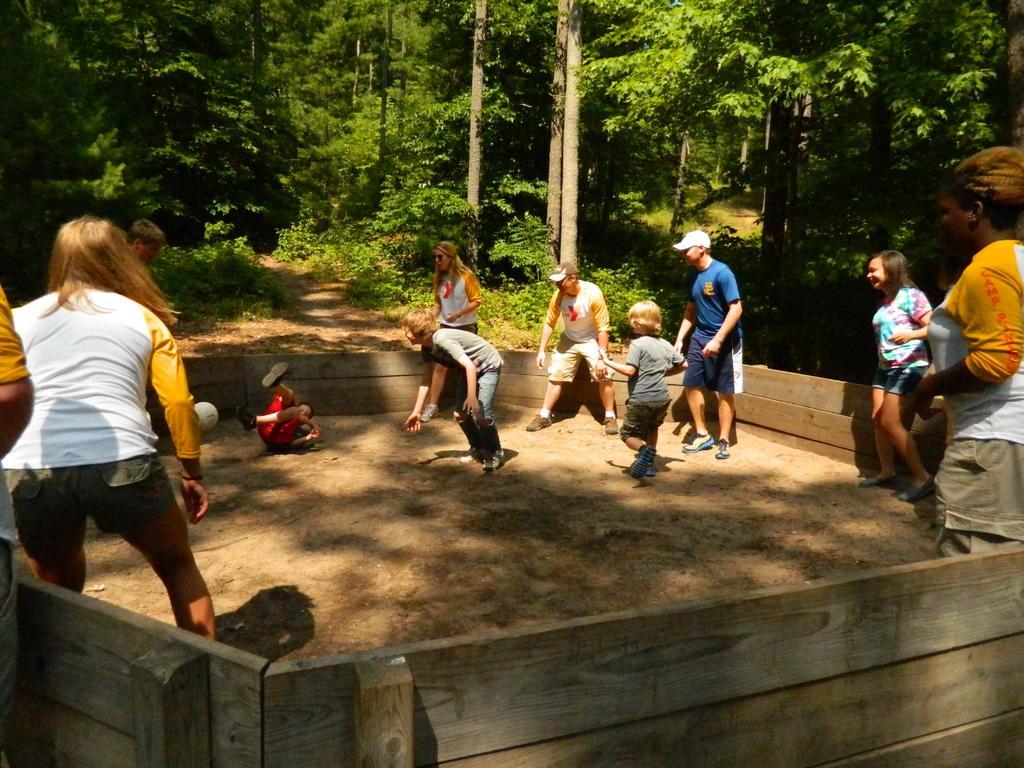Can you describe this image briefly? In this image I can see few people are wearing different color dresses. Back I can see few trees and the wooden fencing. 